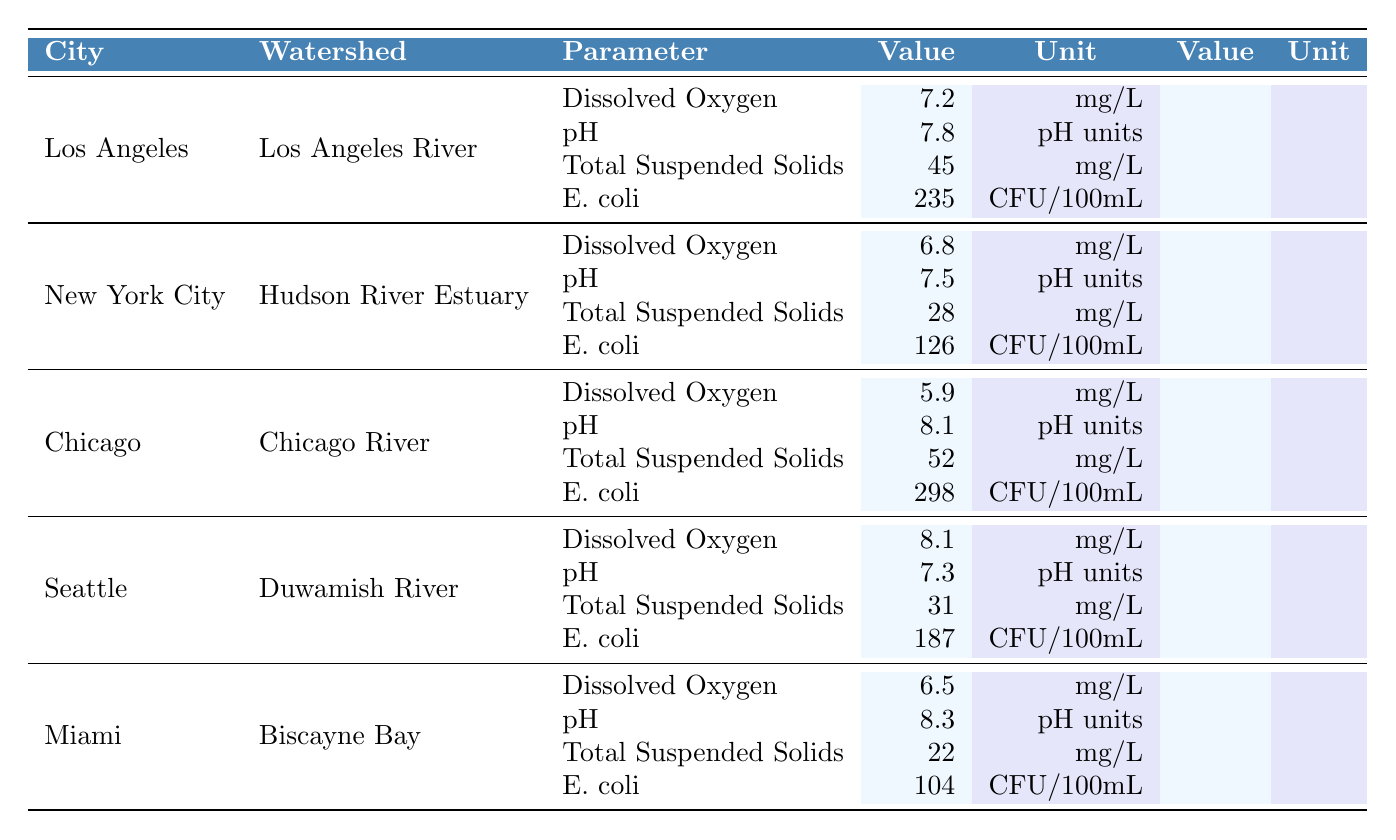What is the dissolved oxygen level in the Duwamish River? The table shows the dissolved oxygen level for the Duwamish River in Seattle as 8.1 mg/L.
Answer: 8.1 mg/L Which city has the highest E. coli count? By comparing the E. coli values, Chicago has the highest count at 298 CFU/100mL.
Answer: Chicago How many cities have a pH level above 8.0? The pH levels are checked for all cities: Chicago (8.1) and Miami (8.3) exceed 8.0, totaling 2 cities.
Answer: 2 cities What is the average total suspended solids value across all watersheds? Total suspended solids values are 45, 28, 52, 31, and 22 mg/L. Summing these gives 178 mg/L, and dividing by 5 gives an average of 35.6 mg/L.
Answer: 35.6 mg/L Is the dissolved oxygen level in the Los Angeles River greater than 7.0 mg/L? The dissolved oxygen level for the Los Angeles River is 7.2 mg/L, which is indeed greater than 7.0 mg/L.
Answer: Yes What is the difference in total suspended solids between the Chicago River and Biscayne Bay? Total suspended solids for Chicago River are 52 mg/L and for Biscayne Bay are 22 mg/L. The difference is 52 - 22 = 30 mg/L.
Answer: 30 mg/L Which watershed has the lowest dissolved oxygen level? Comparing dissolved oxygen levels: Los Angeles River (7.2 mg/L), Hudson River Estuary (6.8 mg/L), Chicago River (5.9 mg/L), Duwamish River (8.1 mg/L), and Biscayne Bay (6.5 mg/L), the lowest level is in the Chicago River.
Answer: Chicago River If the permissible E. coli limit is 200 CFU/100mL, how many watersheds exceed this limit? The table shows E. coli values: Los Angeles River (235), Hudson River Estuary (126), Chicago River (298), Duwamish River (187), and Biscayne Bay (104). Los Angeles River, Chicago River, and Duwamish River exceed 200 CFU/100mL, totaling 3 watersheds.
Answer: 3 watersheds What is the maximum pH value recorded among the watersheds? The pH values are 7.8, 7.5, 8.1, 7.3, and 8.3. The maximum value is 8.3 (Miami).
Answer: 8.3 What is the combined dissolved oxygen level for all watersheds? Adding the dissolved oxygen levels: 7.2 + 6.8 + 5.9 + 8.1 + 6.5 = 34.5 mg/L for all watersheds.
Answer: 34.5 mg/L 